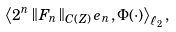<formula> <loc_0><loc_0><loc_500><loc_500>\left \langle 2 ^ { n } \left \| F _ { n } \right \| _ { C ( Z ) } e _ { n } , \Phi ( \cdot ) \right \rangle _ { \ell _ { 2 } } ,</formula> 